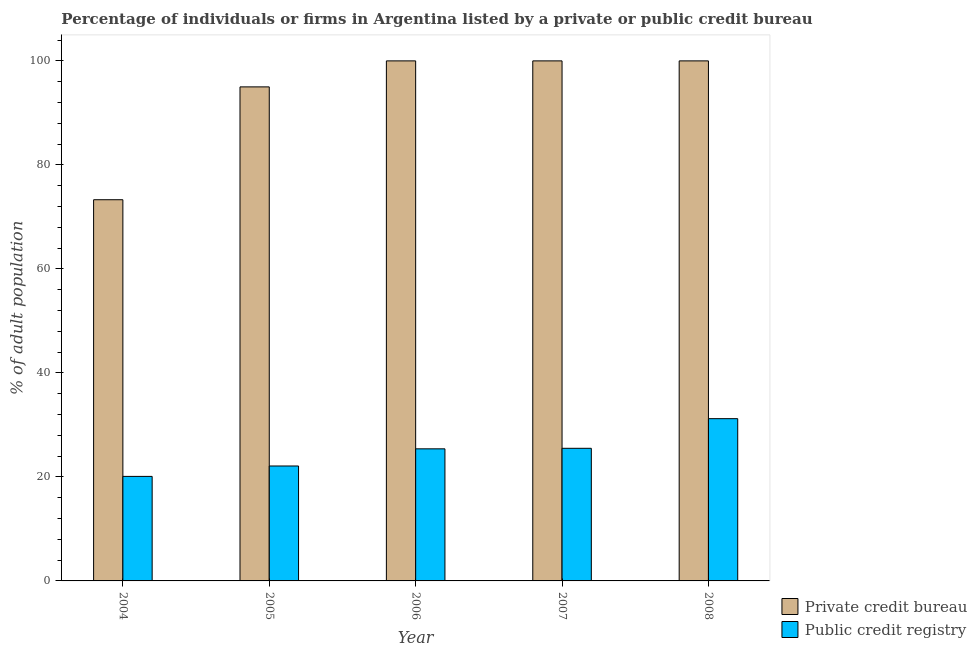How many different coloured bars are there?
Offer a very short reply. 2. How many groups of bars are there?
Ensure brevity in your answer.  5. Are the number of bars on each tick of the X-axis equal?
Ensure brevity in your answer.  Yes. How many bars are there on the 3rd tick from the left?
Make the answer very short. 2. What is the label of the 2nd group of bars from the left?
Offer a very short reply. 2005. In how many cases, is the number of bars for a given year not equal to the number of legend labels?
Offer a terse response. 0. Across all years, what is the maximum percentage of firms listed by public credit bureau?
Keep it short and to the point. 31.2. Across all years, what is the minimum percentage of firms listed by public credit bureau?
Provide a short and direct response. 20.1. In which year was the percentage of firms listed by private credit bureau minimum?
Your answer should be very brief. 2004. What is the total percentage of firms listed by public credit bureau in the graph?
Provide a succinct answer. 124.3. What is the difference between the percentage of firms listed by private credit bureau in 2004 and that in 2006?
Keep it short and to the point. -26.7. What is the difference between the percentage of firms listed by private credit bureau in 2006 and the percentage of firms listed by public credit bureau in 2004?
Keep it short and to the point. 26.7. What is the average percentage of firms listed by public credit bureau per year?
Your answer should be very brief. 24.86. In the year 2007, what is the difference between the percentage of firms listed by public credit bureau and percentage of firms listed by private credit bureau?
Ensure brevity in your answer.  0. In how many years, is the percentage of firms listed by private credit bureau greater than 28 %?
Your answer should be very brief. 5. What is the ratio of the percentage of firms listed by public credit bureau in 2006 to that in 2007?
Your answer should be very brief. 1. Is the percentage of firms listed by private credit bureau in 2006 less than that in 2008?
Give a very brief answer. No. What is the difference between the highest and the second highest percentage of firms listed by public credit bureau?
Provide a succinct answer. 5.7. What is the difference between the highest and the lowest percentage of firms listed by public credit bureau?
Ensure brevity in your answer.  11.1. In how many years, is the percentage of firms listed by public credit bureau greater than the average percentage of firms listed by public credit bureau taken over all years?
Your answer should be compact. 3. Is the sum of the percentage of firms listed by public credit bureau in 2004 and 2007 greater than the maximum percentage of firms listed by private credit bureau across all years?
Provide a succinct answer. Yes. What does the 2nd bar from the left in 2007 represents?
Provide a short and direct response. Public credit registry. What does the 2nd bar from the right in 2008 represents?
Give a very brief answer. Private credit bureau. How many years are there in the graph?
Provide a short and direct response. 5. What is the difference between two consecutive major ticks on the Y-axis?
Your answer should be very brief. 20. Does the graph contain any zero values?
Provide a short and direct response. No. Does the graph contain grids?
Provide a succinct answer. No. How many legend labels are there?
Your response must be concise. 2. What is the title of the graph?
Make the answer very short. Percentage of individuals or firms in Argentina listed by a private or public credit bureau. Does "Investment in Transport" appear as one of the legend labels in the graph?
Make the answer very short. No. What is the label or title of the X-axis?
Keep it short and to the point. Year. What is the label or title of the Y-axis?
Offer a very short reply. % of adult population. What is the % of adult population in Private credit bureau in 2004?
Offer a terse response. 73.3. What is the % of adult population in Public credit registry in 2004?
Keep it short and to the point. 20.1. What is the % of adult population in Public credit registry in 2005?
Make the answer very short. 22.1. What is the % of adult population of Public credit registry in 2006?
Keep it short and to the point. 25.4. What is the % of adult population of Private credit bureau in 2008?
Give a very brief answer. 100. What is the % of adult population of Public credit registry in 2008?
Your response must be concise. 31.2. Across all years, what is the maximum % of adult population of Private credit bureau?
Your answer should be compact. 100. Across all years, what is the maximum % of adult population in Public credit registry?
Provide a succinct answer. 31.2. Across all years, what is the minimum % of adult population of Private credit bureau?
Provide a succinct answer. 73.3. Across all years, what is the minimum % of adult population of Public credit registry?
Your answer should be compact. 20.1. What is the total % of adult population of Private credit bureau in the graph?
Make the answer very short. 468.3. What is the total % of adult population of Public credit registry in the graph?
Make the answer very short. 124.3. What is the difference between the % of adult population of Private credit bureau in 2004 and that in 2005?
Make the answer very short. -21.7. What is the difference between the % of adult population of Private credit bureau in 2004 and that in 2006?
Provide a short and direct response. -26.7. What is the difference between the % of adult population of Public credit registry in 2004 and that in 2006?
Provide a succinct answer. -5.3. What is the difference between the % of adult population in Private credit bureau in 2004 and that in 2007?
Give a very brief answer. -26.7. What is the difference between the % of adult population of Private credit bureau in 2004 and that in 2008?
Keep it short and to the point. -26.7. What is the difference between the % of adult population of Private credit bureau in 2005 and that in 2008?
Provide a succinct answer. -5. What is the difference between the % of adult population of Public credit registry in 2005 and that in 2008?
Keep it short and to the point. -9.1. What is the difference between the % of adult population of Private credit bureau in 2006 and that in 2007?
Give a very brief answer. 0. What is the difference between the % of adult population of Public credit registry in 2006 and that in 2007?
Your response must be concise. -0.1. What is the difference between the % of adult population of Private credit bureau in 2006 and that in 2008?
Make the answer very short. 0. What is the difference between the % of adult population in Public credit registry in 2006 and that in 2008?
Ensure brevity in your answer.  -5.8. What is the difference between the % of adult population in Private credit bureau in 2007 and that in 2008?
Provide a short and direct response. 0. What is the difference between the % of adult population in Private credit bureau in 2004 and the % of adult population in Public credit registry in 2005?
Your answer should be very brief. 51.2. What is the difference between the % of adult population of Private credit bureau in 2004 and the % of adult population of Public credit registry in 2006?
Make the answer very short. 47.9. What is the difference between the % of adult population of Private credit bureau in 2004 and the % of adult population of Public credit registry in 2007?
Keep it short and to the point. 47.8. What is the difference between the % of adult population in Private credit bureau in 2004 and the % of adult population in Public credit registry in 2008?
Your answer should be compact. 42.1. What is the difference between the % of adult population of Private credit bureau in 2005 and the % of adult population of Public credit registry in 2006?
Make the answer very short. 69.6. What is the difference between the % of adult population in Private credit bureau in 2005 and the % of adult population in Public credit registry in 2007?
Keep it short and to the point. 69.5. What is the difference between the % of adult population of Private credit bureau in 2005 and the % of adult population of Public credit registry in 2008?
Give a very brief answer. 63.8. What is the difference between the % of adult population of Private credit bureau in 2006 and the % of adult population of Public credit registry in 2007?
Offer a very short reply. 74.5. What is the difference between the % of adult population in Private credit bureau in 2006 and the % of adult population in Public credit registry in 2008?
Your response must be concise. 68.8. What is the difference between the % of adult population in Private credit bureau in 2007 and the % of adult population in Public credit registry in 2008?
Your answer should be compact. 68.8. What is the average % of adult population of Private credit bureau per year?
Your answer should be very brief. 93.66. What is the average % of adult population in Public credit registry per year?
Make the answer very short. 24.86. In the year 2004, what is the difference between the % of adult population of Private credit bureau and % of adult population of Public credit registry?
Provide a short and direct response. 53.2. In the year 2005, what is the difference between the % of adult population of Private credit bureau and % of adult population of Public credit registry?
Ensure brevity in your answer.  72.9. In the year 2006, what is the difference between the % of adult population in Private credit bureau and % of adult population in Public credit registry?
Make the answer very short. 74.6. In the year 2007, what is the difference between the % of adult population in Private credit bureau and % of adult population in Public credit registry?
Give a very brief answer. 74.5. In the year 2008, what is the difference between the % of adult population of Private credit bureau and % of adult population of Public credit registry?
Ensure brevity in your answer.  68.8. What is the ratio of the % of adult population in Private credit bureau in 2004 to that in 2005?
Give a very brief answer. 0.77. What is the ratio of the % of adult population of Public credit registry in 2004 to that in 2005?
Keep it short and to the point. 0.91. What is the ratio of the % of adult population of Private credit bureau in 2004 to that in 2006?
Offer a very short reply. 0.73. What is the ratio of the % of adult population in Public credit registry in 2004 to that in 2006?
Provide a succinct answer. 0.79. What is the ratio of the % of adult population of Private credit bureau in 2004 to that in 2007?
Provide a short and direct response. 0.73. What is the ratio of the % of adult population of Public credit registry in 2004 to that in 2007?
Provide a succinct answer. 0.79. What is the ratio of the % of adult population of Private credit bureau in 2004 to that in 2008?
Provide a succinct answer. 0.73. What is the ratio of the % of adult population in Public credit registry in 2004 to that in 2008?
Provide a succinct answer. 0.64. What is the ratio of the % of adult population of Private credit bureau in 2005 to that in 2006?
Your answer should be very brief. 0.95. What is the ratio of the % of adult population in Public credit registry in 2005 to that in 2006?
Offer a very short reply. 0.87. What is the ratio of the % of adult population of Private credit bureau in 2005 to that in 2007?
Give a very brief answer. 0.95. What is the ratio of the % of adult population of Public credit registry in 2005 to that in 2007?
Make the answer very short. 0.87. What is the ratio of the % of adult population in Public credit registry in 2005 to that in 2008?
Provide a succinct answer. 0.71. What is the ratio of the % of adult population in Private credit bureau in 2006 to that in 2007?
Your answer should be compact. 1. What is the ratio of the % of adult population of Public credit registry in 2006 to that in 2007?
Make the answer very short. 1. What is the ratio of the % of adult population of Private credit bureau in 2006 to that in 2008?
Offer a terse response. 1. What is the ratio of the % of adult population of Public credit registry in 2006 to that in 2008?
Provide a succinct answer. 0.81. What is the ratio of the % of adult population in Private credit bureau in 2007 to that in 2008?
Your response must be concise. 1. What is the ratio of the % of adult population of Public credit registry in 2007 to that in 2008?
Provide a short and direct response. 0.82. What is the difference between the highest and the lowest % of adult population in Private credit bureau?
Provide a succinct answer. 26.7. What is the difference between the highest and the lowest % of adult population of Public credit registry?
Your response must be concise. 11.1. 